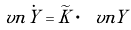<formula> <loc_0><loc_0><loc_500><loc_500>\ v n { \dot { Y } } = \widetilde { K } \cdot \ v n Y \,</formula> 